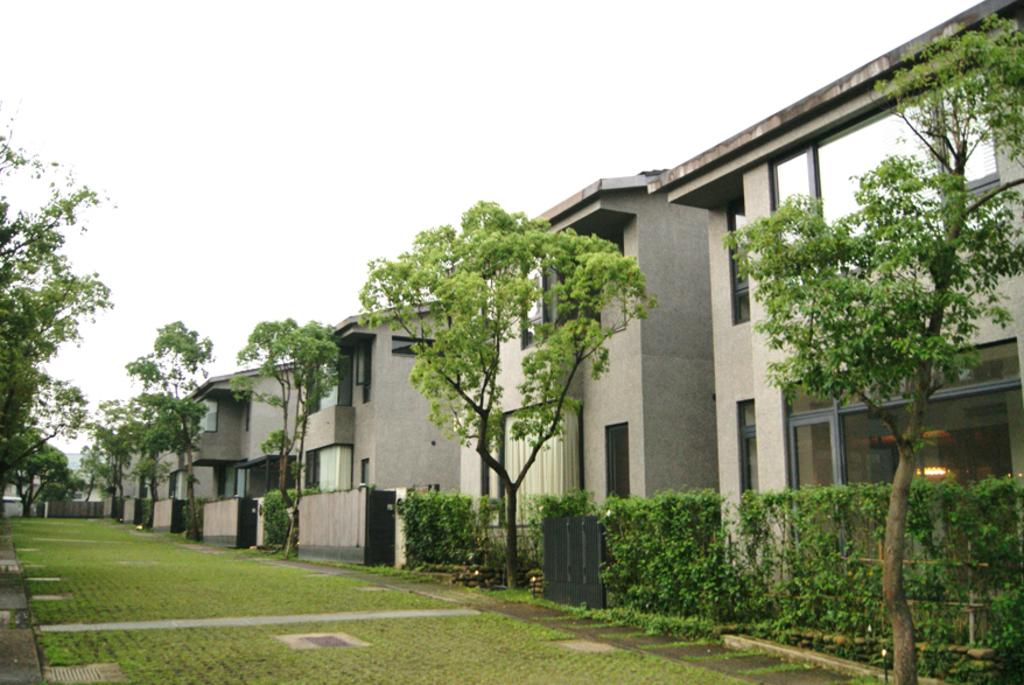What type of structures can be seen in the image? There are buildings in the image. What other natural elements are present in the image? There are trees in the image. Can you describe the path visible in the image? The path has green grass in the image. What type of nerve is visible in the image? There is no nerve visible in the image; it features buildings, trees, and a path with green grass. What title is given to the image? The provided facts do not mention a title for the image. 